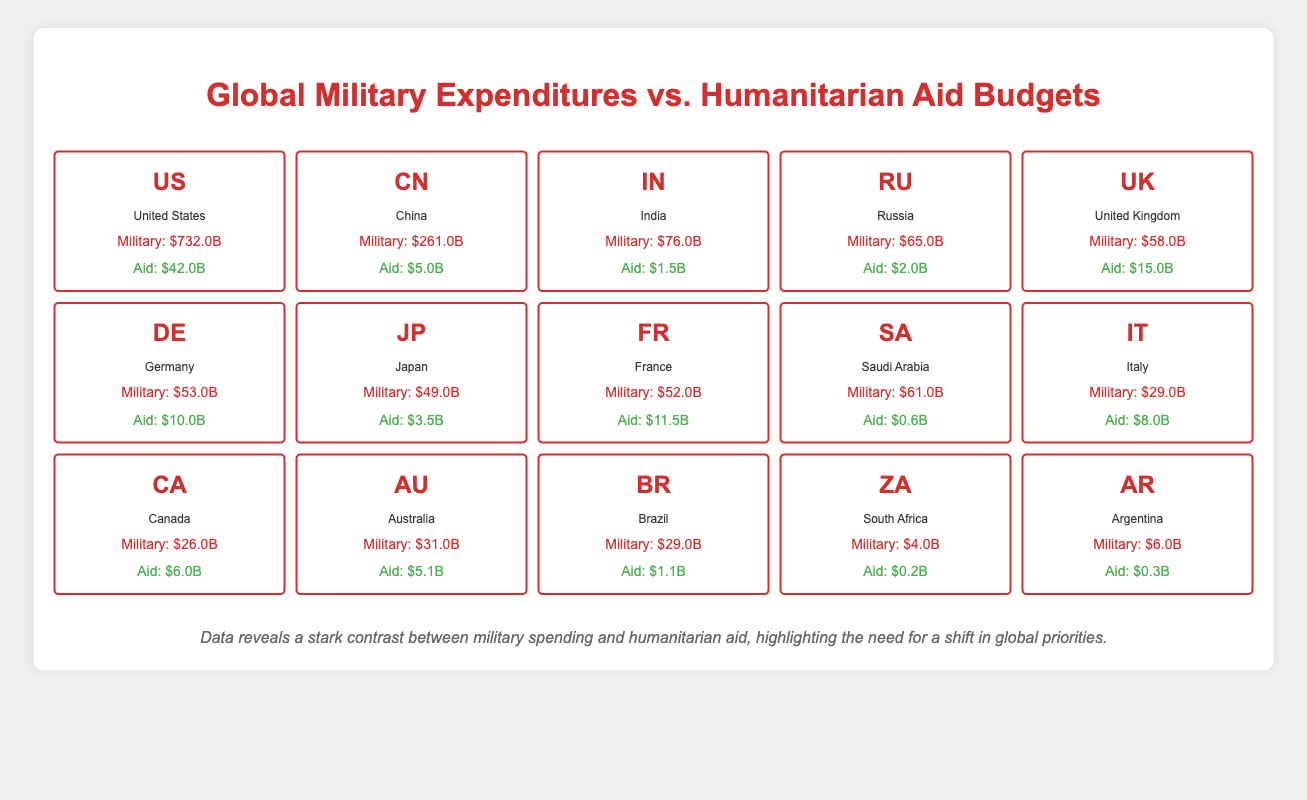What is the military expenditure of the United States? The table lists the military expenditure of the United States as $732.0B.
Answer: $732.0B Which country has the lowest military expenditure? Looking through the table, South Africa has the lowest military expenditure at $4.0B.
Answer: South Africa What is the total humanitarian aid provided by Germany and the United Kingdom combined? Adding the humanitarian aid of Germany ($10.0B) and the United Kingdom ($15.0B) gives 10.0 + 15.0 = 25.0B.
Answer: $25.0B Is it true that Japan's military expenditure is greater than its humanitarian aid budget? Comparing the military expenditure of Japan ($49.0B) with its humanitarian aid budget ($3.5B), military spending is indeed greater.
Answer: Yes What is the difference between the military expenditures of the United States and China? The military expenditure of the United States is $732.0B and that of China is $261.0B. The difference is 732.0 - 261.0 = 471.0B.
Answer: $471.0B Which country among the listed has the highest ratio of humanitarian aid to military expenditure? To find the highest ratio, calculate the ratio for each country by dividing humanitarian aid by military expenditure. For example, in the UK, the ratio is 15.0/58.0 = 0.2586, for Canada it's 6.0/26.0 = 0.2308, etc. Calculating all, we find that the UK has the highest ratio of approximately 0.2586.
Answer: United Kingdom How much more does Saudi Arabia spend on military compared to humanitarian aid? Saudi Arabia spends $61.0B on military and $0.6B on humanitarian aid. The difference is 61.0 - 0.6 = 60.4B.
Answer: $60.4B What is the total military expenditure of the top three countries listed? The top three countries are the United States ($732.0B), China ($261.0B), and India ($76.0B). Summing these gives 732.0 + 261.0 + 76.0 = 1069.0B.
Answer: $1069.0B True or False: Humanitarian aid from Russia is greater than its military expenditure. Russia's military expenditure is $65.0B, and humanitarian aid is $2.0B, indicating aid is not greater than military.
Answer: False 